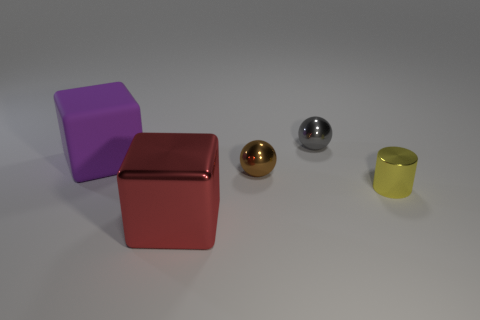Add 4 small brown shiny things. How many objects exist? 9 Subtract all blocks. How many objects are left? 3 Subtract 0 blue balls. How many objects are left? 5 Subtract all red blocks. Subtract all big purple matte cubes. How many objects are left? 3 Add 1 big rubber objects. How many big rubber objects are left? 2 Add 5 big rubber objects. How many big rubber objects exist? 6 